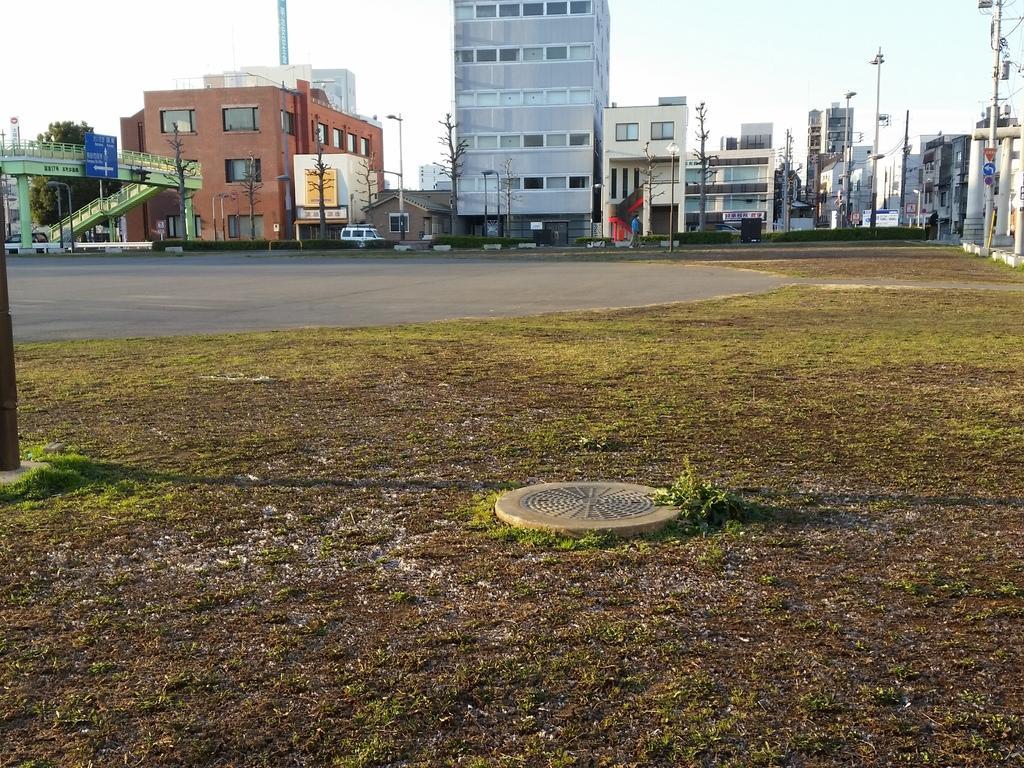Can you describe this image briefly? In this image I can see the ground, some grass, the manhole lid, the road and in the background I can see few trees, few buildings, few metal poles and the sky. 